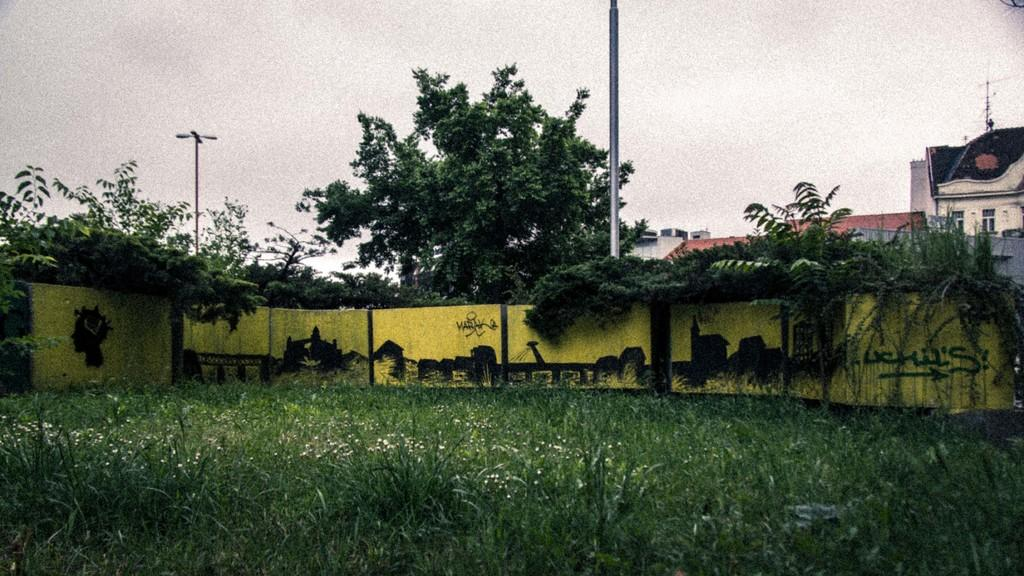What type of vegetation is at the bottom of the image? There is grass at the bottom of the image. What structure is located in the center of the image? There is a fence in the center of the image. What can be seen in the background of the image? There are poles, trees, and buildings in the background of the image. What is visible at the top of the image? The sky is visible at the top of the image. What type of music can be heard coming from the beast in the image? There is no beast or music present in the image. How many birds are in the flock depicted in the image? There is no flock or birds present in the image. 